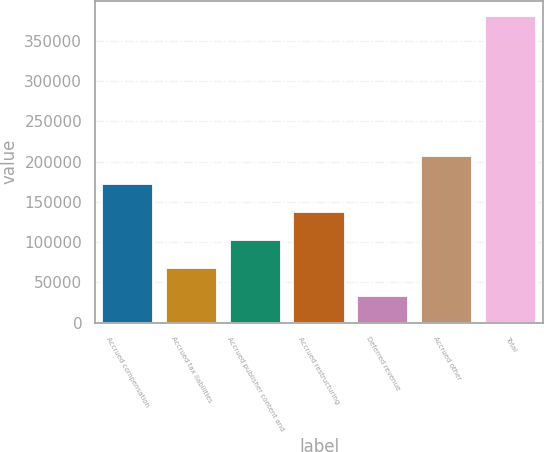Convert chart to OTSL. <chart><loc_0><loc_0><loc_500><loc_500><bar_chart><fcel>Accrued compensation<fcel>Accrued tax liabilities<fcel>Accrued publisher content and<fcel>Accrued restructuring<fcel>Deferred revenue<fcel>Accrued other<fcel>Total<nl><fcel>172570<fcel>68386.8<fcel>103115<fcel>137842<fcel>33659<fcel>207298<fcel>380937<nl></chart> 